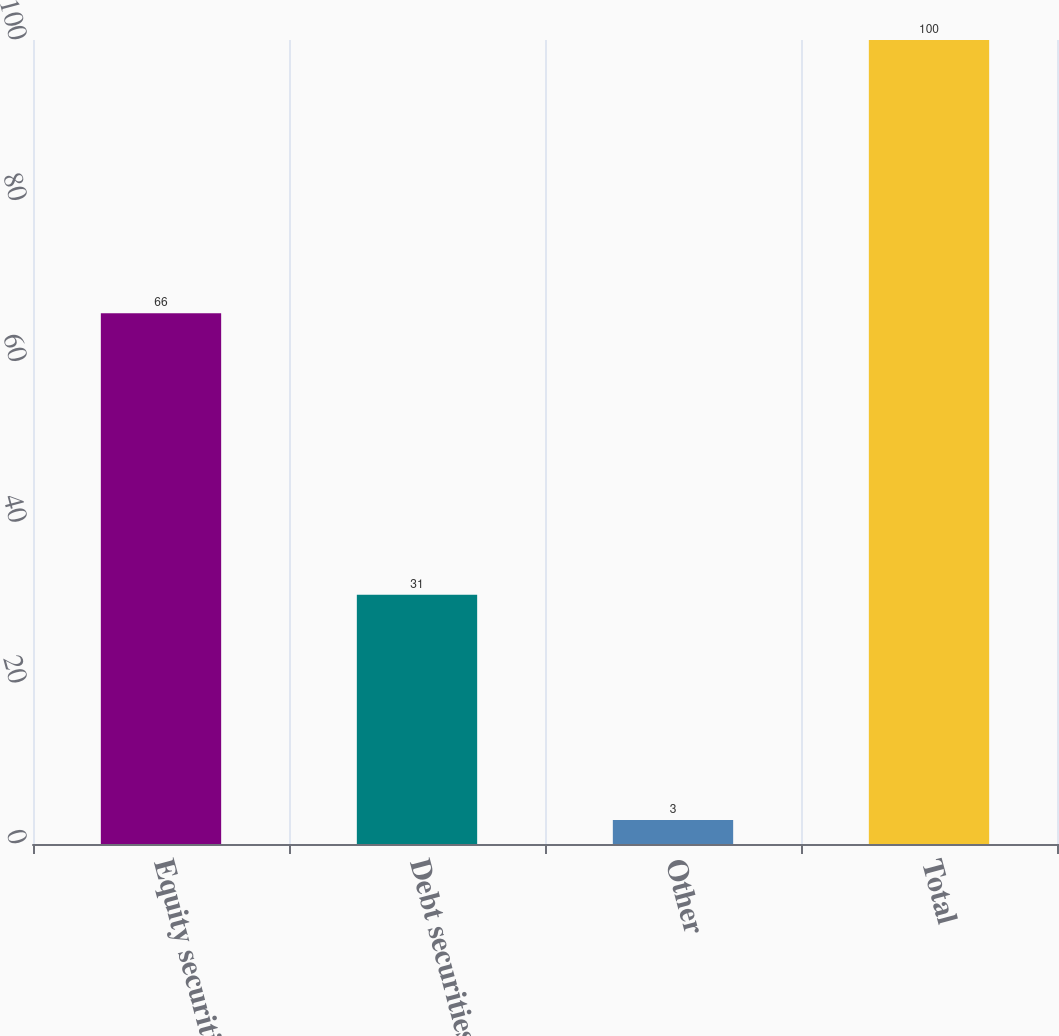Convert chart to OTSL. <chart><loc_0><loc_0><loc_500><loc_500><bar_chart><fcel>Equity securities<fcel>Debt securities<fcel>Other<fcel>Total<nl><fcel>66<fcel>31<fcel>3<fcel>100<nl></chart> 